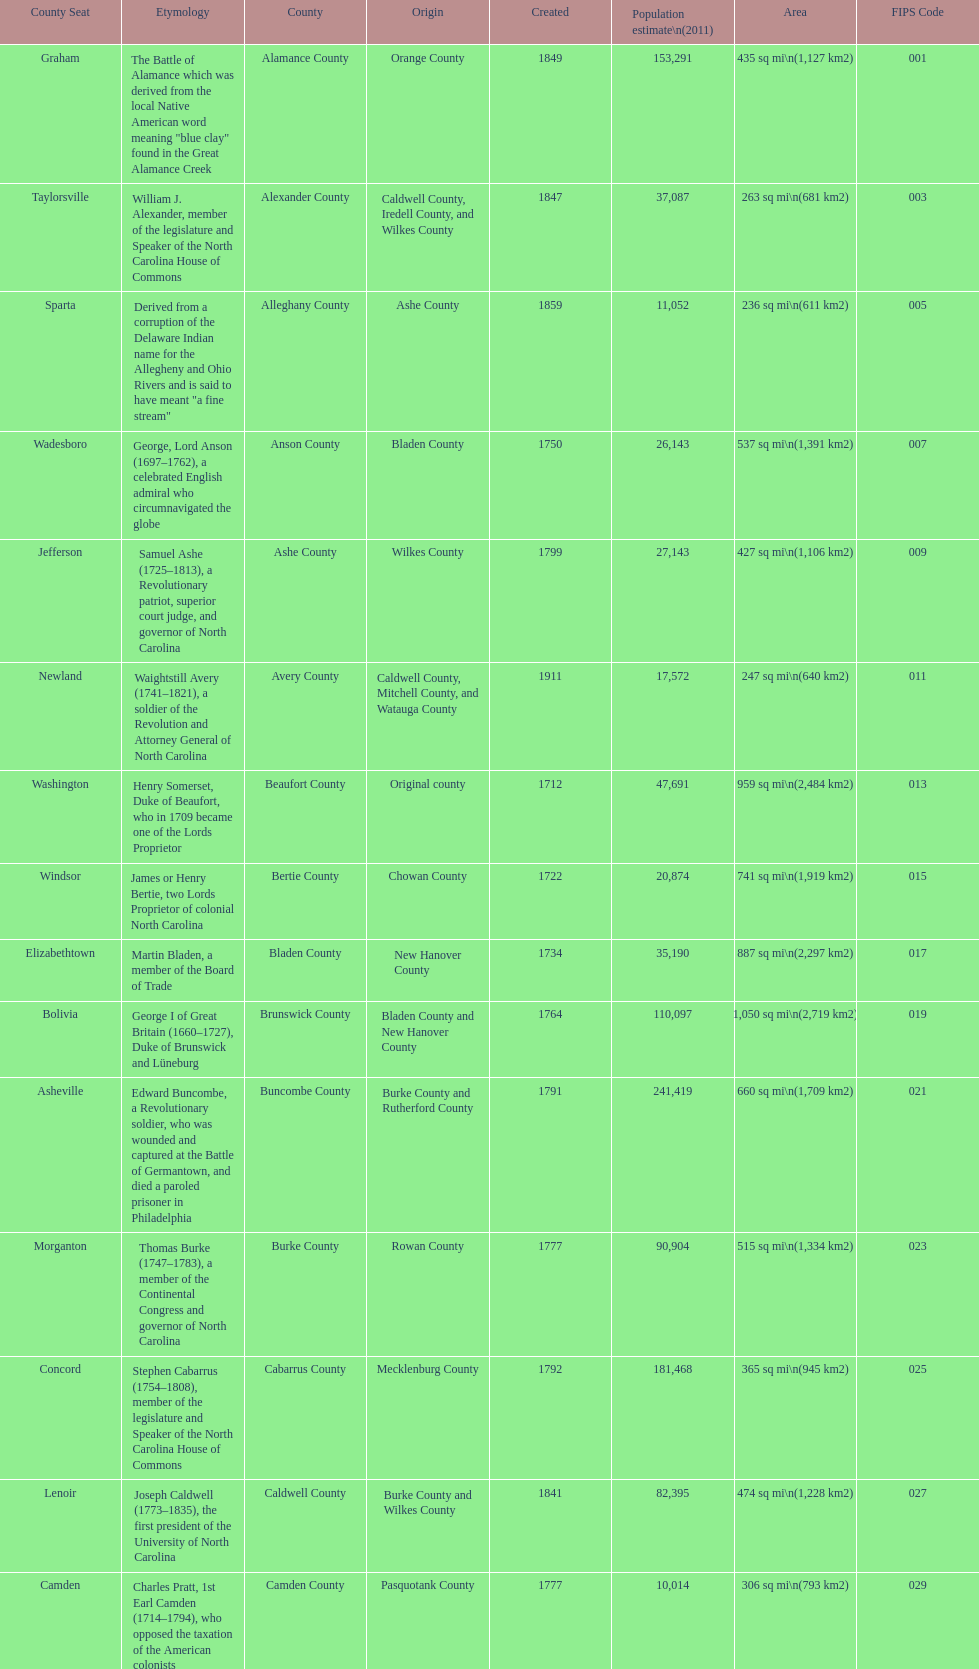What is the only county whose name comes from a battle? Alamance County. 